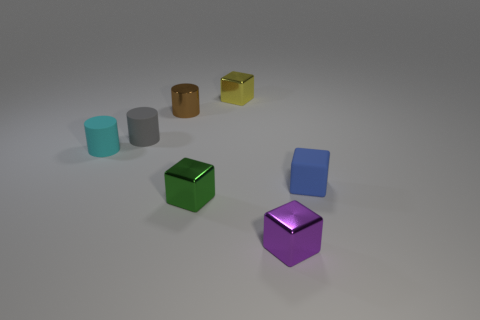Subtract 1 cubes. How many cubes are left? 3 Add 2 tiny cyan objects. How many objects exist? 9 Subtract all cubes. How many objects are left? 3 Add 4 small yellow metallic things. How many small yellow metallic things are left? 5 Add 2 large green matte blocks. How many large green matte blocks exist? 2 Subtract 1 brown cylinders. How many objects are left? 6 Subtract all small cyan matte blocks. Subtract all small brown things. How many objects are left? 6 